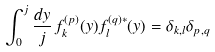Convert formula to latex. <formula><loc_0><loc_0><loc_500><loc_500>\int _ { 0 } ^ { j } \frac { d y } { j } \, f ^ { ( p ) } _ { k } ( y ) f ^ { ( q ) * } _ { l } ( y ) = \delta _ { k , l } \delta _ { p , q }</formula> 